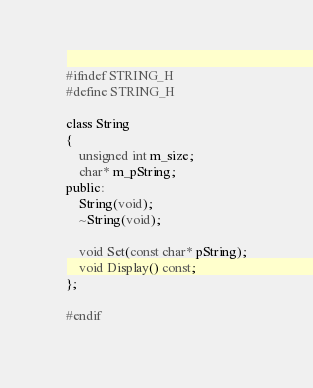Convert code to text. <code><loc_0><loc_0><loc_500><loc_500><_C_>#ifndef STRING_H
#define STRING_H

class String
{
	unsigned int m_size;
	char* m_pString;
public:
	String(void);
	~String(void);

	void Set(const char* pString);
	void Display() const;
};

#endif</code> 